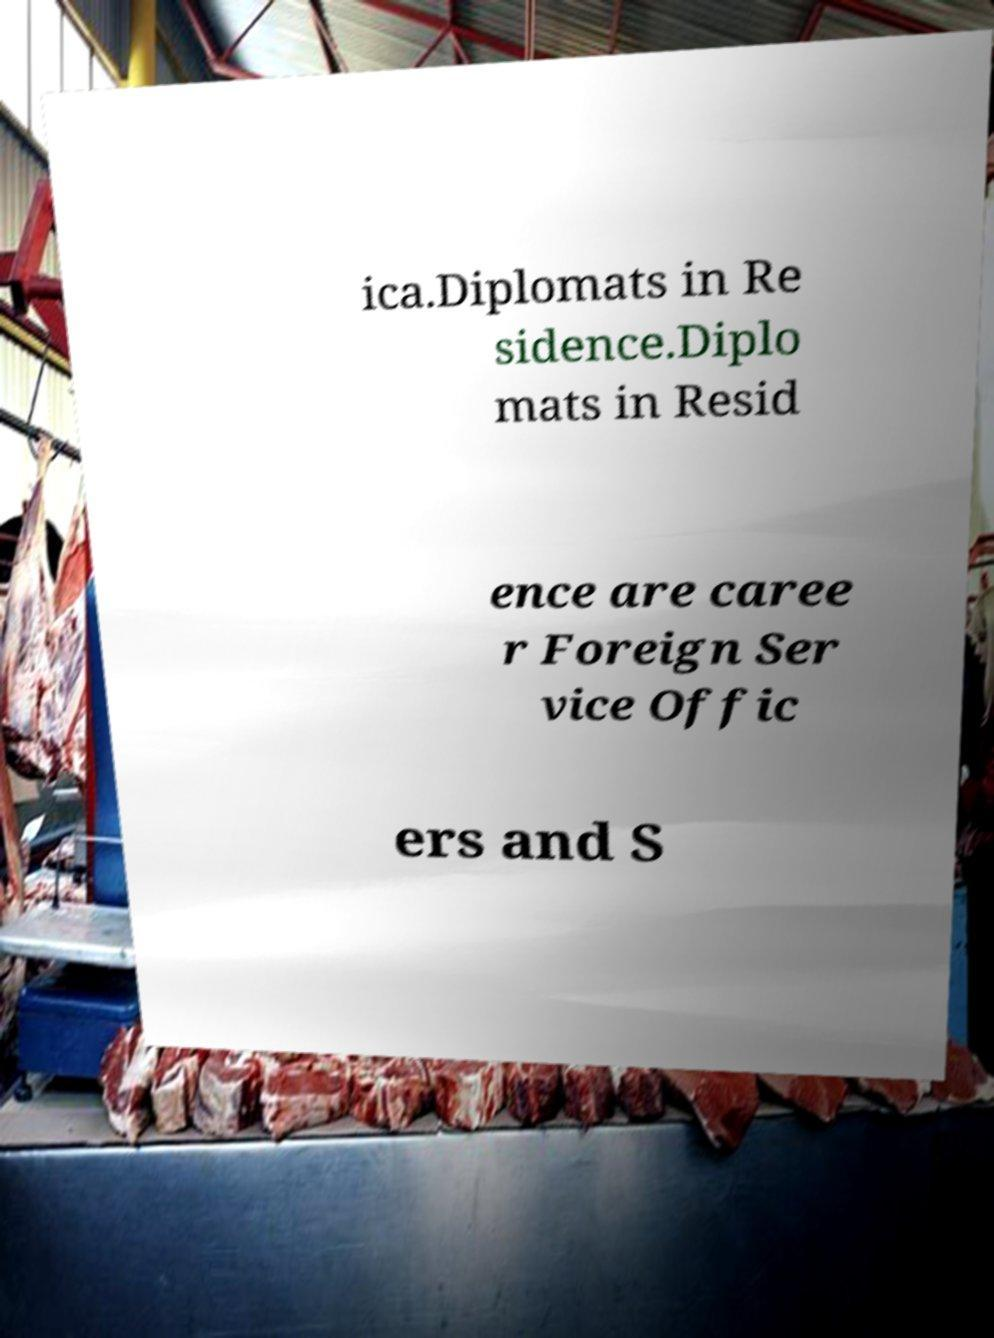Please identify and transcribe the text found in this image. ica.Diplomats in Re sidence.Diplo mats in Resid ence are caree r Foreign Ser vice Offic ers and S 